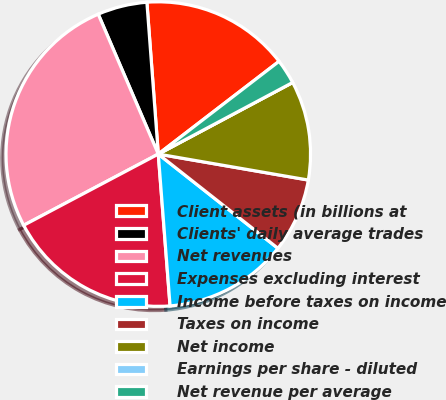Convert chart. <chart><loc_0><loc_0><loc_500><loc_500><pie_chart><fcel>Client assets (in billions at<fcel>Clients' daily average trades<fcel>Net revenues<fcel>Expenses excluding interest<fcel>Income before taxes on income<fcel>Taxes on income<fcel>Net income<fcel>Earnings per share - diluted<fcel>Net revenue per average<nl><fcel>15.77%<fcel>5.26%<fcel>26.29%<fcel>18.49%<fcel>13.15%<fcel>7.89%<fcel>10.52%<fcel>0.0%<fcel>2.63%<nl></chart> 